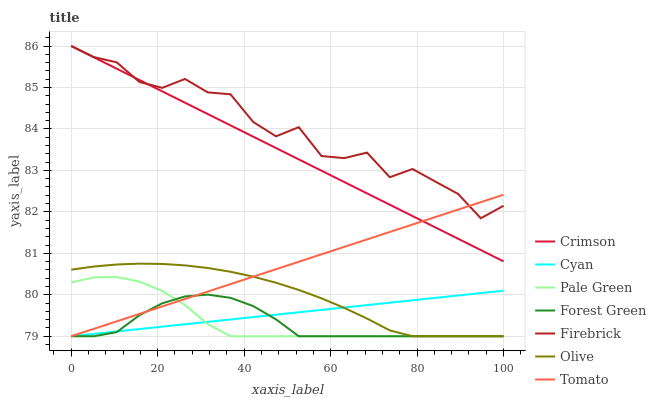Does Forest Green have the minimum area under the curve?
Answer yes or no. Yes. Does Firebrick have the maximum area under the curve?
Answer yes or no. Yes. Does Olive have the minimum area under the curve?
Answer yes or no. No. Does Olive have the maximum area under the curve?
Answer yes or no. No. Is Crimson the smoothest?
Answer yes or no. Yes. Is Firebrick the roughest?
Answer yes or no. Yes. Is Olive the smoothest?
Answer yes or no. No. Is Olive the roughest?
Answer yes or no. No. Does Tomato have the lowest value?
Answer yes or no. Yes. Does Firebrick have the lowest value?
Answer yes or no. No. Does Crimson have the highest value?
Answer yes or no. Yes. Does Olive have the highest value?
Answer yes or no. No. Is Olive less than Crimson?
Answer yes or no. Yes. Is Firebrick greater than Cyan?
Answer yes or no. Yes. Does Pale Green intersect Olive?
Answer yes or no. Yes. Is Pale Green less than Olive?
Answer yes or no. No. Is Pale Green greater than Olive?
Answer yes or no. No. Does Olive intersect Crimson?
Answer yes or no. No. 